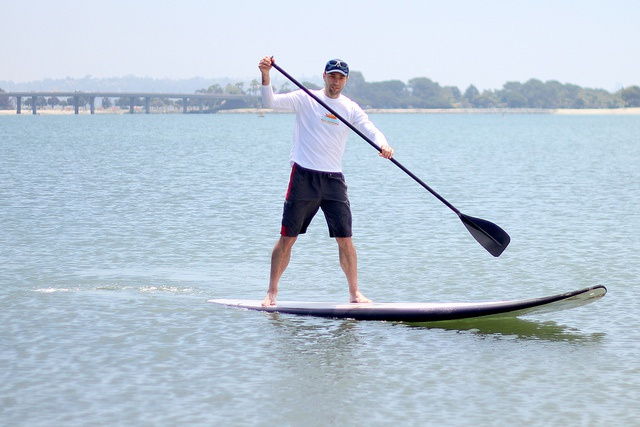Describe the objects in this image and their specific colors. I can see people in lavender, black, and brown tones and surfboard in lavender, black, darkgray, and gray tones in this image. 